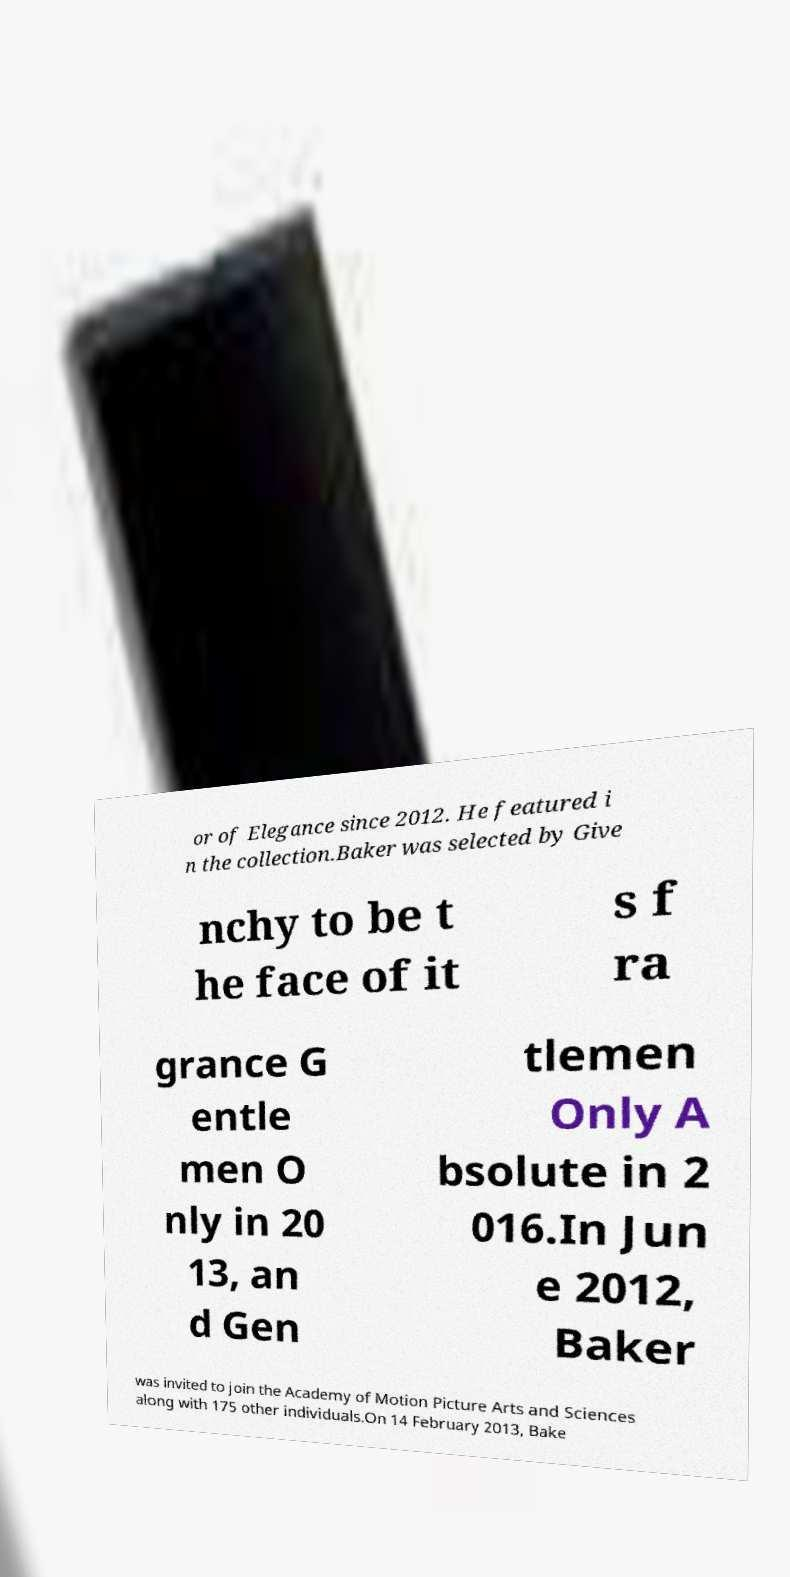Can you accurately transcribe the text from the provided image for me? or of Elegance since 2012. He featured i n the collection.Baker was selected by Give nchy to be t he face of it s f ra grance G entle men O nly in 20 13, an d Gen tlemen Only A bsolute in 2 016.In Jun e 2012, Baker was invited to join the Academy of Motion Picture Arts and Sciences along with 175 other individuals.On 14 February 2013, Bake 